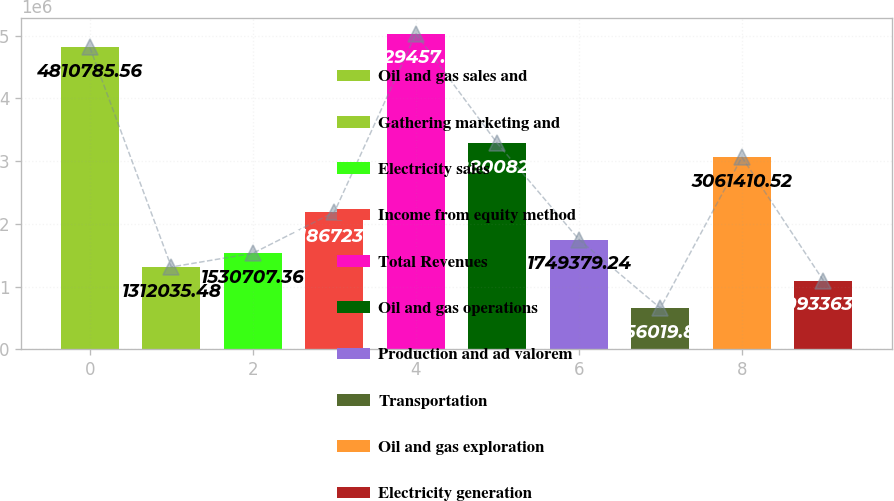Convert chart to OTSL. <chart><loc_0><loc_0><loc_500><loc_500><bar_chart><fcel>Oil and gas sales and<fcel>Gathering marketing and<fcel>Electricity sales<fcel>Income from equity method<fcel>Total Revenues<fcel>Oil and gas operations<fcel>Production and ad valorem<fcel>Transportation<fcel>Oil and gas exploration<fcel>Electricity generation<nl><fcel>4.81079e+06<fcel>1.31204e+06<fcel>1.53071e+06<fcel>2.18672e+06<fcel>5.02946e+06<fcel>3.28008e+06<fcel>1.74938e+06<fcel>656020<fcel>3.06141e+06<fcel>1.09336e+06<nl></chart> 